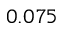<formula> <loc_0><loc_0><loc_500><loc_500>0 . 0 7 5</formula> 